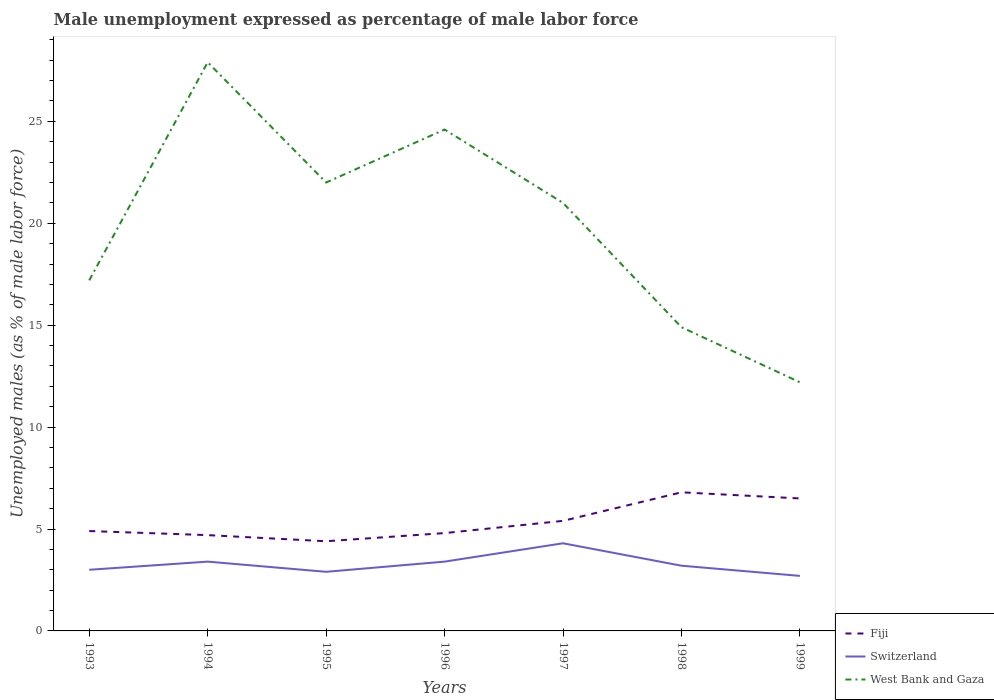Across all years, what is the maximum unemployment in males in in Fiji?
Give a very brief answer. 4.4. In which year was the unemployment in males in in Switzerland maximum?
Your answer should be very brief. 1999. What is the total unemployment in males in in West Bank and Gaza in the graph?
Provide a short and direct response. 6.9. What is the difference between the highest and the second highest unemployment in males in in Fiji?
Offer a terse response. 2.4. What is the difference between the highest and the lowest unemployment in males in in Fiji?
Your response must be concise. 3. Is the unemployment in males in in Fiji strictly greater than the unemployment in males in in West Bank and Gaza over the years?
Give a very brief answer. Yes. How many lines are there?
Provide a short and direct response. 3. How many years are there in the graph?
Ensure brevity in your answer.  7. Are the values on the major ticks of Y-axis written in scientific E-notation?
Offer a terse response. No. Does the graph contain any zero values?
Give a very brief answer. No. Does the graph contain grids?
Your answer should be compact. No. Where does the legend appear in the graph?
Make the answer very short. Bottom right. How many legend labels are there?
Make the answer very short. 3. What is the title of the graph?
Give a very brief answer. Male unemployment expressed as percentage of male labor force. Does "Low income" appear as one of the legend labels in the graph?
Your answer should be very brief. No. What is the label or title of the X-axis?
Provide a short and direct response. Years. What is the label or title of the Y-axis?
Provide a succinct answer. Unemployed males (as % of male labor force). What is the Unemployed males (as % of male labor force) of Fiji in 1993?
Your response must be concise. 4.9. What is the Unemployed males (as % of male labor force) in West Bank and Gaza in 1993?
Your answer should be very brief. 17.2. What is the Unemployed males (as % of male labor force) of Fiji in 1994?
Your response must be concise. 4.7. What is the Unemployed males (as % of male labor force) in Switzerland in 1994?
Your answer should be very brief. 3.4. What is the Unemployed males (as % of male labor force) in West Bank and Gaza in 1994?
Ensure brevity in your answer.  27.9. What is the Unemployed males (as % of male labor force) in Fiji in 1995?
Your answer should be compact. 4.4. What is the Unemployed males (as % of male labor force) in Switzerland in 1995?
Your answer should be compact. 2.9. What is the Unemployed males (as % of male labor force) in West Bank and Gaza in 1995?
Your answer should be very brief. 22. What is the Unemployed males (as % of male labor force) of Fiji in 1996?
Offer a very short reply. 4.8. What is the Unemployed males (as % of male labor force) in Switzerland in 1996?
Provide a short and direct response. 3.4. What is the Unemployed males (as % of male labor force) in West Bank and Gaza in 1996?
Offer a very short reply. 24.6. What is the Unemployed males (as % of male labor force) in Fiji in 1997?
Ensure brevity in your answer.  5.4. What is the Unemployed males (as % of male labor force) in Switzerland in 1997?
Provide a short and direct response. 4.3. What is the Unemployed males (as % of male labor force) in Fiji in 1998?
Ensure brevity in your answer.  6.8. What is the Unemployed males (as % of male labor force) in Switzerland in 1998?
Your response must be concise. 3.2. What is the Unemployed males (as % of male labor force) in West Bank and Gaza in 1998?
Provide a short and direct response. 14.9. What is the Unemployed males (as % of male labor force) in Fiji in 1999?
Offer a terse response. 6.5. What is the Unemployed males (as % of male labor force) in Switzerland in 1999?
Provide a short and direct response. 2.7. What is the Unemployed males (as % of male labor force) in West Bank and Gaza in 1999?
Provide a short and direct response. 12.2. Across all years, what is the maximum Unemployed males (as % of male labor force) in Fiji?
Your answer should be very brief. 6.8. Across all years, what is the maximum Unemployed males (as % of male labor force) in Switzerland?
Keep it short and to the point. 4.3. Across all years, what is the maximum Unemployed males (as % of male labor force) in West Bank and Gaza?
Ensure brevity in your answer.  27.9. Across all years, what is the minimum Unemployed males (as % of male labor force) of Fiji?
Make the answer very short. 4.4. Across all years, what is the minimum Unemployed males (as % of male labor force) in Switzerland?
Your answer should be very brief. 2.7. Across all years, what is the minimum Unemployed males (as % of male labor force) of West Bank and Gaza?
Your response must be concise. 12.2. What is the total Unemployed males (as % of male labor force) in Fiji in the graph?
Provide a succinct answer. 37.5. What is the total Unemployed males (as % of male labor force) in Switzerland in the graph?
Make the answer very short. 22.9. What is the total Unemployed males (as % of male labor force) in West Bank and Gaza in the graph?
Your response must be concise. 139.8. What is the difference between the Unemployed males (as % of male labor force) in Switzerland in 1993 and that in 1994?
Ensure brevity in your answer.  -0.4. What is the difference between the Unemployed males (as % of male labor force) of West Bank and Gaza in 1993 and that in 1994?
Your answer should be compact. -10.7. What is the difference between the Unemployed males (as % of male labor force) in Fiji in 1993 and that in 1995?
Provide a succinct answer. 0.5. What is the difference between the Unemployed males (as % of male labor force) of Fiji in 1993 and that in 1996?
Provide a short and direct response. 0.1. What is the difference between the Unemployed males (as % of male labor force) of Switzerland in 1993 and that in 1996?
Your answer should be compact. -0.4. What is the difference between the Unemployed males (as % of male labor force) of Fiji in 1993 and that in 1997?
Your response must be concise. -0.5. What is the difference between the Unemployed males (as % of male labor force) in West Bank and Gaza in 1993 and that in 1997?
Offer a very short reply. -3.8. What is the difference between the Unemployed males (as % of male labor force) of Fiji in 1993 and that in 1999?
Your answer should be very brief. -1.6. What is the difference between the Unemployed males (as % of male labor force) in West Bank and Gaza in 1993 and that in 1999?
Keep it short and to the point. 5. What is the difference between the Unemployed males (as % of male labor force) of Fiji in 1994 and that in 1995?
Offer a terse response. 0.3. What is the difference between the Unemployed males (as % of male labor force) of Fiji in 1994 and that in 1996?
Your answer should be compact. -0.1. What is the difference between the Unemployed males (as % of male labor force) in West Bank and Gaza in 1994 and that in 1996?
Offer a very short reply. 3.3. What is the difference between the Unemployed males (as % of male labor force) of Fiji in 1994 and that in 1997?
Your answer should be very brief. -0.7. What is the difference between the Unemployed males (as % of male labor force) of Switzerland in 1994 and that in 1997?
Provide a succinct answer. -0.9. What is the difference between the Unemployed males (as % of male labor force) in West Bank and Gaza in 1994 and that in 1997?
Make the answer very short. 6.9. What is the difference between the Unemployed males (as % of male labor force) of Switzerland in 1994 and that in 1998?
Provide a succinct answer. 0.2. What is the difference between the Unemployed males (as % of male labor force) in Switzerland in 1994 and that in 1999?
Provide a short and direct response. 0.7. What is the difference between the Unemployed males (as % of male labor force) in Fiji in 1995 and that in 1996?
Make the answer very short. -0.4. What is the difference between the Unemployed males (as % of male labor force) of West Bank and Gaza in 1995 and that in 1997?
Make the answer very short. 1. What is the difference between the Unemployed males (as % of male labor force) of Switzerland in 1995 and that in 1999?
Your answer should be very brief. 0.2. What is the difference between the Unemployed males (as % of male labor force) in West Bank and Gaza in 1995 and that in 1999?
Offer a very short reply. 9.8. What is the difference between the Unemployed males (as % of male labor force) in Fiji in 1996 and that in 1997?
Provide a succinct answer. -0.6. What is the difference between the Unemployed males (as % of male labor force) of West Bank and Gaza in 1996 and that in 1998?
Provide a short and direct response. 9.7. What is the difference between the Unemployed males (as % of male labor force) in Fiji in 1996 and that in 1999?
Keep it short and to the point. -1.7. What is the difference between the Unemployed males (as % of male labor force) of Fiji in 1997 and that in 1998?
Ensure brevity in your answer.  -1.4. What is the difference between the Unemployed males (as % of male labor force) in Switzerland in 1997 and that in 1999?
Make the answer very short. 1.6. What is the difference between the Unemployed males (as % of male labor force) in West Bank and Gaza in 1998 and that in 1999?
Offer a very short reply. 2.7. What is the difference between the Unemployed males (as % of male labor force) in Fiji in 1993 and the Unemployed males (as % of male labor force) in Switzerland in 1994?
Offer a terse response. 1.5. What is the difference between the Unemployed males (as % of male labor force) of Switzerland in 1993 and the Unemployed males (as % of male labor force) of West Bank and Gaza in 1994?
Offer a terse response. -24.9. What is the difference between the Unemployed males (as % of male labor force) of Fiji in 1993 and the Unemployed males (as % of male labor force) of Switzerland in 1995?
Provide a short and direct response. 2. What is the difference between the Unemployed males (as % of male labor force) in Fiji in 1993 and the Unemployed males (as % of male labor force) in West Bank and Gaza in 1995?
Your response must be concise. -17.1. What is the difference between the Unemployed males (as % of male labor force) in Switzerland in 1993 and the Unemployed males (as % of male labor force) in West Bank and Gaza in 1995?
Give a very brief answer. -19. What is the difference between the Unemployed males (as % of male labor force) in Fiji in 1993 and the Unemployed males (as % of male labor force) in West Bank and Gaza in 1996?
Offer a very short reply. -19.7. What is the difference between the Unemployed males (as % of male labor force) of Switzerland in 1993 and the Unemployed males (as % of male labor force) of West Bank and Gaza in 1996?
Your answer should be compact. -21.6. What is the difference between the Unemployed males (as % of male labor force) of Fiji in 1993 and the Unemployed males (as % of male labor force) of Switzerland in 1997?
Offer a very short reply. 0.6. What is the difference between the Unemployed males (as % of male labor force) in Fiji in 1993 and the Unemployed males (as % of male labor force) in West Bank and Gaza in 1997?
Make the answer very short. -16.1. What is the difference between the Unemployed males (as % of male labor force) in Switzerland in 1993 and the Unemployed males (as % of male labor force) in West Bank and Gaza in 1997?
Provide a short and direct response. -18. What is the difference between the Unemployed males (as % of male labor force) of Fiji in 1993 and the Unemployed males (as % of male labor force) of Switzerland in 1998?
Your answer should be compact. 1.7. What is the difference between the Unemployed males (as % of male labor force) of Switzerland in 1993 and the Unemployed males (as % of male labor force) of West Bank and Gaza in 1999?
Your answer should be very brief. -9.2. What is the difference between the Unemployed males (as % of male labor force) in Fiji in 1994 and the Unemployed males (as % of male labor force) in West Bank and Gaza in 1995?
Your answer should be compact. -17.3. What is the difference between the Unemployed males (as % of male labor force) of Switzerland in 1994 and the Unemployed males (as % of male labor force) of West Bank and Gaza in 1995?
Offer a terse response. -18.6. What is the difference between the Unemployed males (as % of male labor force) of Fiji in 1994 and the Unemployed males (as % of male labor force) of West Bank and Gaza in 1996?
Your answer should be compact. -19.9. What is the difference between the Unemployed males (as % of male labor force) in Switzerland in 1994 and the Unemployed males (as % of male labor force) in West Bank and Gaza in 1996?
Your response must be concise. -21.2. What is the difference between the Unemployed males (as % of male labor force) in Fiji in 1994 and the Unemployed males (as % of male labor force) in Switzerland in 1997?
Make the answer very short. 0.4. What is the difference between the Unemployed males (as % of male labor force) of Fiji in 1994 and the Unemployed males (as % of male labor force) of West Bank and Gaza in 1997?
Ensure brevity in your answer.  -16.3. What is the difference between the Unemployed males (as % of male labor force) in Switzerland in 1994 and the Unemployed males (as % of male labor force) in West Bank and Gaza in 1997?
Provide a short and direct response. -17.6. What is the difference between the Unemployed males (as % of male labor force) in Fiji in 1994 and the Unemployed males (as % of male labor force) in West Bank and Gaza in 1998?
Provide a succinct answer. -10.2. What is the difference between the Unemployed males (as % of male labor force) in Switzerland in 1994 and the Unemployed males (as % of male labor force) in West Bank and Gaza in 1999?
Your answer should be very brief. -8.8. What is the difference between the Unemployed males (as % of male labor force) of Fiji in 1995 and the Unemployed males (as % of male labor force) of Switzerland in 1996?
Your response must be concise. 1. What is the difference between the Unemployed males (as % of male labor force) of Fiji in 1995 and the Unemployed males (as % of male labor force) of West Bank and Gaza in 1996?
Provide a short and direct response. -20.2. What is the difference between the Unemployed males (as % of male labor force) of Switzerland in 1995 and the Unemployed males (as % of male labor force) of West Bank and Gaza in 1996?
Your response must be concise. -21.7. What is the difference between the Unemployed males (as % of male labor force) of Fiji in 1995 and the Unemployed males (as % of male labor force) of Switzerland in 1997?
Your answer should be compact. 0.1. What is the difference between the Unemployed males (as % of male labor force) in Fiji in 1995 and the Unemployed males (as % of male labor force) in West Bank and Gaza in 1997?
Offer a very short reply. -16.6. What is the difference between the Unemployed males (as % of male labor force) of Switzerland in 1995 and the Unemployed males (as % of male labor force) of West Bank and Gaza in 1997?
Your answer should be compact. -18.1. What is the difference between the Unemployed males (as % of male labor force) of Switzerland in 1995 and the Unemployed males (as % of male labor force) of West Bank and Gaza in 1998?
Your answer should be compact. -12. What is the difference between the Unemployed males (as % of male labor force) in Switzerland in 1995 and the Unemployed males (as % of male labor force) in West Bank and Gaza in 1999?
Your response must be concise. -9.3. What is the difference between the Unemployed males (as % of male labor force) of Fiji in 1996 and the Unemployed males (as % of male labor force) of Switzerland in 1997?
Keep it short and to the point. 0.5. What is the difference between the Unemployed males (as % of male labor force) in Fiji in 1996 and the Unemployed males (as % of male labor force) in West Bank and Gaza in 1997?
Provide a short and direct response. -16.2. What is the difference between the Unemployed males (as % of male labor force) of Switzerland in 1996 and the Unemployed males (as % of male labor force) of West Bank and Gaza in 1997?
Provide a succinct answer. -17.6. What is the difference between the Unemployed males (as % of male labor force) of Fiji in 1996 and the Unemployed males (as % of male labor force) of Switzerland in 1998?
Ensure brevity in your answer.  1.6. What is the difference between the Unemployed males (as % of male labor force) of Fiji in 1996 and the Unemployed males (as % of male labor force) of West Bank and Gaza in 1998?
Your answer should be compact. -10.1. What is the difference between the Unemployed males (as % of male labor force) in Fiji in 1996 and the Unemployed males (as % of male labor force) in Switzerland in 1999?
Your answer should be compact. 2.1. What is the difference between the Unemployed males (as % of male labor force) in Fiji in 1996 and the Unemployed males (as % of male labor force) in West Bank and Gaza in 1999?
Your answer should be very brief. -7.4. What is the difference between the Unemployed males (as % of male labor force) in Switzerland in 1996 and the Unemployed males (as % of male labor force) in West Bank and Gaza in 1999?
Your answer should be compact. -8.8. What is the difference between the Unemployed males (as % of male labor force) of Fiji in 1997 and the Unemployed males (as % of male labor force) of West Bank and Gaza in 1998?
Offer a very short reply. -9.5. What is the difference between the Unemployed males (as % of male labor force) of Switzerland in 1997 and the Unemployed males (as % of male labor force) of West Bank and Gaza in 1998?
Your answer should be very brief. -10.6. What is the difference between the Unemployed males (as % of male labor force) of Fiji in 1997 and the Unemployed males (as % of male labor force) of Switzerland in 1999?
Your answer should be very brief. 2.7. What is the difference between the Unemployed males (as % of male labor force) in Fiji in 1997 and the Unemployed males (as % of male labor force) in West Bank and Gaza in 1999?
Provide a succinct answer. -6.8. What is the average Unemployed males (as % of male labor force) of Fiji per year?
Your answer should be very brief. 5.36. What is the average Unemployed males (as % of male labor force) of Switzerland per year?
Give a very brief answer. 3.27. What is the average Unemployed males (as % of male labor force) of West Bank and Gaza per year?
Offer a very short reply. 19.97. In the year 1993, what is the difference between the Unemployed males (as % of male labor force) in Fiji and Unemployed males (as % of male labor force) in Switzerland?
Your answer should be compact. 1.9. In the year 1994, what is the difference between the Unemployed males (as % of male labor force) in Fiji and Unemployed males (as % of male labor force) in West Bank and Gaza?
Give a very brief answer. -23.2. In the year 1994, what is the difference between the Unemployed males (as % of male labor force) in Switzerland and Unemployed males (as % of male labor force) in West Bank and Gaza?
Provide a short and direct response. -24.5. In the year 1995, what is the difference between the Unemployed males (as % of male labor force) of Fiji and Unemployed males (as % of male labor force) of Switzerland?
Ensure brevity in your answer.  1.5. In the year 1995, what is the difference between the Unemployed males (as % of male labor force) of Fiji and Unemployed males (as % of male labor force) of West Bank and Gaza?
Provide a short and direct response. -17.6. In the year 1995, what is the difference between the Unemployed males (as % of male labor force) of Switzerland and Unemployed males (as % of male labor force) of West Bank and Gaza?
Give a very brief answer. -19.1. In the year 1996, what is the difference between the Unemployed males (as % of male labor force) in Fiji and Unemployed males (as % of male labor force) in Switzerland?
Keep it short and to the point. 1.4. In the year 1996, what is the difference between the Unemployed males (as % of male labor force) in Fiji and Unemployed males (as % of male labor force) in West Bank and Gaza?
Your answer should be compact. -19.8. In the year 1996, what is the difference between the Unemployed males (as % of male labor force) of Switzerland and Unemployed males (as % of male labor force) of West Bank and Gaza?
Keep it short and to the point. -21.2. In the year 1997, what is the difference between the Unemployed males (as % of male labor force) in Fiji and Unemployed males (as % of male labor force) in Switzerland?
Your response must be concise. 1.1. In the year 1997, what is the difference between the Unemployed males (as % of male labor force) of Fiji and Unemployed males (as % of male labor force) of West Bank and Gaza?
Make the answer very short. -15.6. In the year 1997, what is the difference between the Unemployed males (as % of male labor force) of Switzerland and Unemployed males (as % of male labor force) of West Bank and Gaza?
Provide a succinct answer. -16.7. In the year 1998, what is the difference between the Unemployed males (as % of male labor force) in Fiji and Unemployed males (as % of male labor force) in West Bank and Gaza?
Keep it short and to the point. -8.1. In the year 1999, what is the difference between the Unemployed males (as % of male labor force) of Fiji and Unemployed males (as % of male labor force) of Switzerland?
Offer a terse response. 3.8. In the year 1999, what is the difference between the Unemployed males (as % of male labor force) in Switzerland and Unemployed males (as % of male labor force) in West Bank and Gaza?
Make the answer very short. -9.5. What is the ratio of the Unemployed males (as % of male labor force) in Fiji in 1993 to that in 1994?
Give a very brief answer. 1.04. What is the ratio of the Unemployed males (as % of male labor force) of Switzerland in 1993 to that in 1994?
Provide a short and direct response. 0.88. What is the ratio of the Unemployed males (as % of male labor force) of West Bank and Gaza in 1993 to that in 1994?
Your answer should be compact. 0.62. What is the ratio of the Unemployed males (as % of male labor force) of Fiji in 1993 to that in 1995?
Offer a very short reply. 1.11. What is the ratio of the Unemployed males (as % of male labor force) of Switzerland in 1993 to that in 1995?
Your response must be concise. 1.03. What is the ratio of the Unemployed males (as % of male labor force) of West Bank and Gaza in 1993 to that in 1995?
Your answer should be very brief. 0.78. What is the ratio of the Unemployed males (as % of male labor force) in Fiji in 1993 to that in 1996?
Make the answer very short. 1.02. What is the ratio of the Unemployed males (as % of male labor force) of Switzerland in 1993 to that in 1996?
Offer a terse response. 0.88. What is the ratio of the Unemployed males (as % of male labor force) of West Bank and Gaza in 1993 to that in 1996?
Your response must be concise. 0.7. What is the ratio of the Unemployed males (as % of male labor force) in Fiji in 1993 to that in 1997?
Provide a short and direct response. 0.91. What is the ratio of the Unemployed males (as % of male labor force) of Switzerland in 1993 to that in 1997?
Offer a terse response. 0.7. What is the ratio of the Unemployed males (as % of male labor force) of West Bank and Gaza in 1993 to that in 1997?
Your response must be concise. 0.82. What is the ratio of the Unemployed males (as % of male labor force) of Fiji in 1993 to that in 1998?
Give a very brief answer. 0.72. What is the ratio of the Unemployed males (as % of male labor force) of West Bank and Gaza in 1993 to that in 1998?
Provide a short and direct response. 1.15. What is the ratio of the Unemployed males (as % of male labor force) in Fiji in 1993 to that in 1999?
Make the answer very short. 0.75. What is the ratio of the Unemployed males (as % of male labor force) of Switzerland in 1993 to that in 1999?
Your answer should be very brief. 1.11. What is the ratio of the Unemployed males (as % of male labor force) in West Bank and Gaza in 1993 to that in 1999?
Offer a very short reply. 1.41. What is the ratio of the Unemployed males (as % of male labor force) of Fiji in 1994 to that in 1995?
Offer a terse response. 1.07. What is the ratio of the Unemployed males (as % of male labor force) of Switzerland in 1994 to that in 1995?
Ensure brevity in your answer.  1.17. What is the ratio of the Unemployed males (as % of male labor force) of West Bank and Gaza in 1994 to that in 1995?
Give a very brief answer. 1.27. What is the ratio of the Unemployed males (as % of male labor force) in Fiji in 1994 to that in 1996?
Provide a short and direct response. 0.98. What is the ratio of the Unemployed males (as % of male labor force) in West Bank and Gaza in 1994 to that in 1996?
Your answer should be compact. 1.13. What is the ratio of the Unemployed males (as % of male labor force) of Fiji in 1994 to that in 1997?
Your response must be concise. 0.87. What is the ratio of the Unemployed males (as % of male labor force) of Switzerland in 1994 to that in 1997?
Provide a short and direct response. 0.79. What is the ratio of the Unemployed males (as % of male labor force) in West Bank and Gaza in 1994 to that in 1997?
Your response must be concise. 1.33. What is the ratio of the Unemployed males (as % of male labor force) of Fiji in 1994 to that in 1998?
Offer a terse response. 0.69. What is the ratio of the Unemployed males (as % of male labor force) of West Bank and Gaza in 1994 to that in 1998?
Your answer should be very brief. 1.87. What is the ratio of the Unemployed males (as % of male labor force) of Fiji in 1994 to that in 1999?
Ensure brevity in your answer.  0.72. What is the ratio of the Unemployed males (as % of male labor force) in Switzerland in 1994 to that in 1999?
Your answer should be very brief. 1.26. What is the ratio of the Unemployed males (as % of male labor force) in West Bank and Gaza in 1994 to that in 1999?
Offer a terse response. 2.29. What is the ratio of the Unemployed males (as % of male labor force) of Fiji in 1995 to that in 1996?
Your answer should be compact. 0.92. What is the ratio of the Unemployed males (as % of male labor force) of Switzerland in 1995 to that in 1996?
Offer a terse response. 0.85. What is the ratio of the Unemployed males (as % of male labor force) in West Bank and Gaza in 1995 to that in 1996?
Offer a very short reply. 0.89. What is the ratio of the Unemployed males (as % of male labor force) in Fiji in 1995 to that in 1997?
Keep it short and to the point. 0.81. What is the ratio of the Unemployed males (as % of male labor force) of Switzerland in 1995 to that in 1997?
Offer a very short reply. 0.67. What is the ratio of the Unemployed males (as % of male labor force) of West Bank and Gaza in 1995 to that in 1997?
Provide a short and direct response. 1.05. What is the ratio of the Unemployed males (as % of male labor force) of Fiji in 1995 to that in 1998?
Provide a succinct answer. 0.65. What is the ratio of the Unemployed males (as % of male labor force) in Switzerland in 1995 to that in 1998?
Your answer should be compact. 0.91. What is the ratio of the Unemployed males (as % of male labor force) of West Bank and Gaza in 1995 to that in 1998?
Offer a very short reply. 1.48. What is the ratio of the Unemployed males (as % of male labor force) of Fiji in 1995 to that in 1999?
Your answer should be compact. 0.68. What is the ratio of the Unemployed males (as % of male labor force) of Switzerland in 1995 to that in 1999?
Your answer should be very brief. 1.07. What is the ratio of the Unemployed males (as % of male labor force) in West Bank and Gaza in 1995 to that in 1999?
Make the answer very short. 1.8. What is the ratio of the Unemployed males (as % of male labor force) of Fiji in 1996 to that in 1997?
Your answer should be compact. 0.89. What is the ratio of the Unemployed males (as % of male labor force) in Switzerland in 1996 to that in 1997?
Offer a very short reply. 0.79. What is the ratio of the Unemployed males (as % of male labor force) of West Bank and Gaza in 1996 to that in 1997?
Your answer should be very brief. 1.17. What is the ratio of the Unemployed males (as % of male labor force) of Fiji in 1996 to that in 1998?
Keep it short and to the point. 0.71. What is the ratio of the Unemployed males (as % of male labor force) in Switzerland in 1996 to that in 1998?
Your answer should be compact. 1.06. What is the ratio of the Unemployed males (as % of male labor force) in West Bank and Gaza in 1996 to that in 1998?
Your response must be concise. 1.65. What is the ratio of the Unemployed males (as % of male labor force) of Fiji in 1996 to that in 1999?
Give a very brief answer. 0.74. What is the ratio of the Unemployed males (as % of male labor force) in Switzerland in 1996 to that in 1999?
Your answer should be very brief. 1.26. What is the ratio of the Unemployed males (as % of male labor force) of West Bank and Gaza in 1996 to that in 1999?
Your answer should be compact. 2.02. What is the ratio of the Unemployed males (as % of male labor force) of Fiji in 1997 to that in 1998?
Your answer should be compact. 0.79. What is the ratio of the Unemployed males (as % of male labor force) in Switzerland in 1997 to that in 1998?
Offer a terse response. 1.34. What is the ratio of the Unemployed males (as % of male labor force) in West Bank and Gaza in 1997 to that in 1998?
Provide a short and direct response. 1.41. What is the ratio of the Unemployed males (as % of male labor force) in Fiji in 1997 to that in 1999?
Give a very brief answer. 0.83. What is the ratio of the Unemployed males (as % of male labor force) in Switzerland in 1997 to that in 1999?
Keep it short and to the point. 1.59. What is the ratio of the Unemployed males (as % of male labor force) in West Bank and Gaza in 1997 to that in 1999?
Offer a very short reply. 1.72. What is the ratio of the Unemployed males (as % of male labor force) of Fiji in 1998 to that in 1999?
Provide a succinct answer. 1.05. What is the ratio of the Unemployed males (as % of male labor force) of Switzerland in 1998 to that in 1999?
Keep it short and to the point. 1.19. What is the ratio of the Unemployed males (as % of male labor force) in West Bank and Gaza in 1998 to that in 1999?
Offer a terse response. 1.22. What is the difference between the highest and the second highest Unemployed males (as % of male labor force) of Switzerland?
Your response must be concise. 0.9. What is the difference between the highest and the lowest Unemployed males (as % of male labor force) of Fiji?
Provide a succinct answer. 2.4. What is the difference between the highest and the lowest Unemployed males (as % of male labor force) of Switzerland?
Keep it short and to the point. 1.6. 